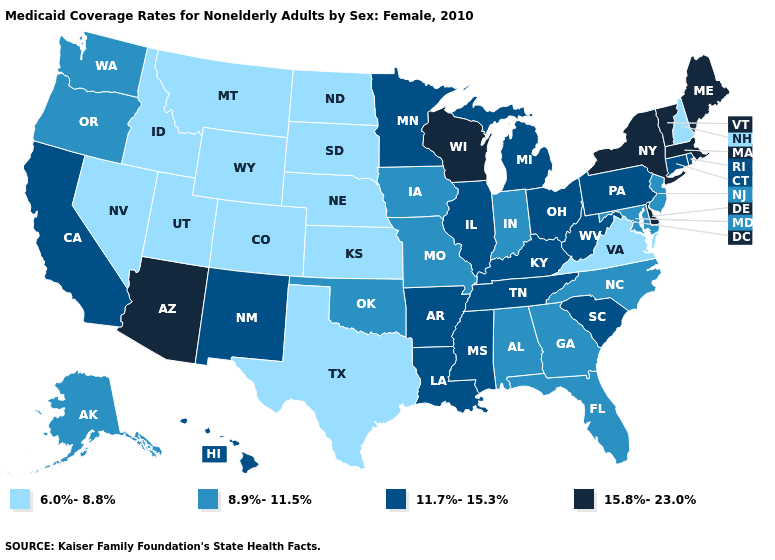Does Pennsylvania have the highest value in the Northeast?
Short answer required. No. Name the states that have a value in the range 6.0%-8.8%?
Quick response, please. Colorado, Idaho, Kansas, Montana, Nebraska, Nevada, New Hampshire, North Dakota, South Dakota, Texas, Utah, Virginia, Wyoming. Name the states that have a value in the range 15.8%-23.0%?
Quick response, please. Arizona, Delaware, Maine, Massachusetts, New York, Vermont, Wisconsin. What is the lowest value in the USA?
Be succinct. 6.0%-8.8%. Does New York have the highest value in the Northeast?
Concise answer only. Yes. Does Arizona have the lowest value in the West?
Short answer required. No. What is the lowest value in the USA?
Give a very brief answer. 6.0%-8.8%. Which states have the lowest value in the USA?
Quick response, please. Colorado, Idaho, Kansas, Montana, Nebraska, Nevada, New Hampshire, North Dakota, South Dakota, Texas, Utah, Virginia, Wyoming. Which states have the highest value in the USA?
Short answer required. Arizona, Delaware, Maine, Massachusetts, New York, Vermont, Wisconsin. What is the highest value in the USA?
Quick response, please. 15.8%-23.0%. What is the highest value in the MidWest ?
Give a very brief answer. 15.8%-23.0%. Does the map have missing data?
Concise answer only. No. How many symbols are there in the legend?
Give a very brief answer. 4. Does the map have missing data?
Write a very short answer. No. What is the lowest value in the USA?
Give a very brief answer. 6.0%-8.8%. 